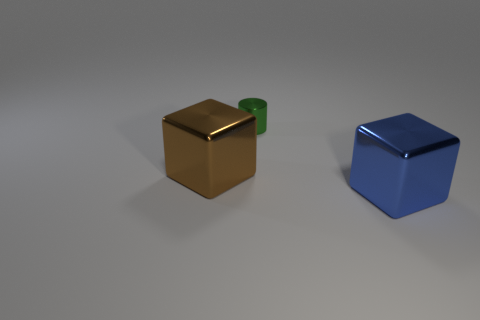Add 2 small cyan metal cylinders. How many objects exist? 5 Subtract all blocks. How many objects are left? 1 Add 2 cyan spheres. How many cyan spheres exist? 2 Subtract 0 gray cubes. How many objects are left? 3 Subtract all yellow metal balls. Subtract all blue metal cubes. How many objects are left? 2 Add 3 green cylinders. How many green cylinders are left? 4 